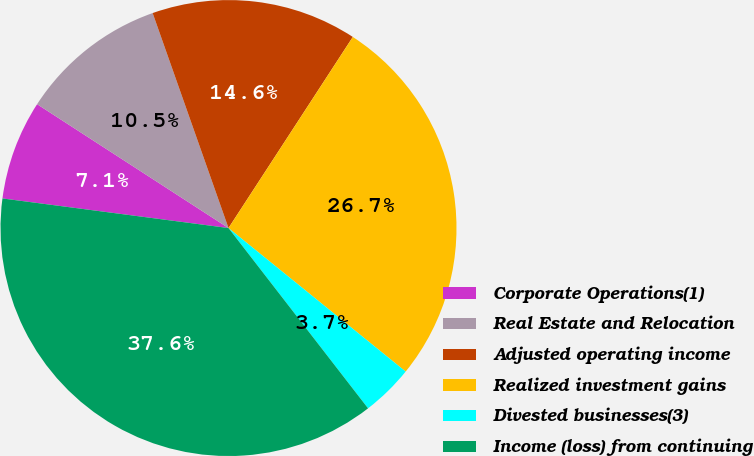<chart> <loc_0><loc_0><loc_500><loc_500><pie_chart><fcel>Corporate Operations(1)<fcel>Real Estate and Relocation<fcel>Adjusted operating income<fcel>Realized investment gains<fcel>Divested businesses(3)<fcel>Income (loss) from continuing<nl><fcel>7.07%<fcel>10.46%<fcel>14.58%<fcel>26.66%<fcel>3.68%<fcel>37.56%<nl></chart> 